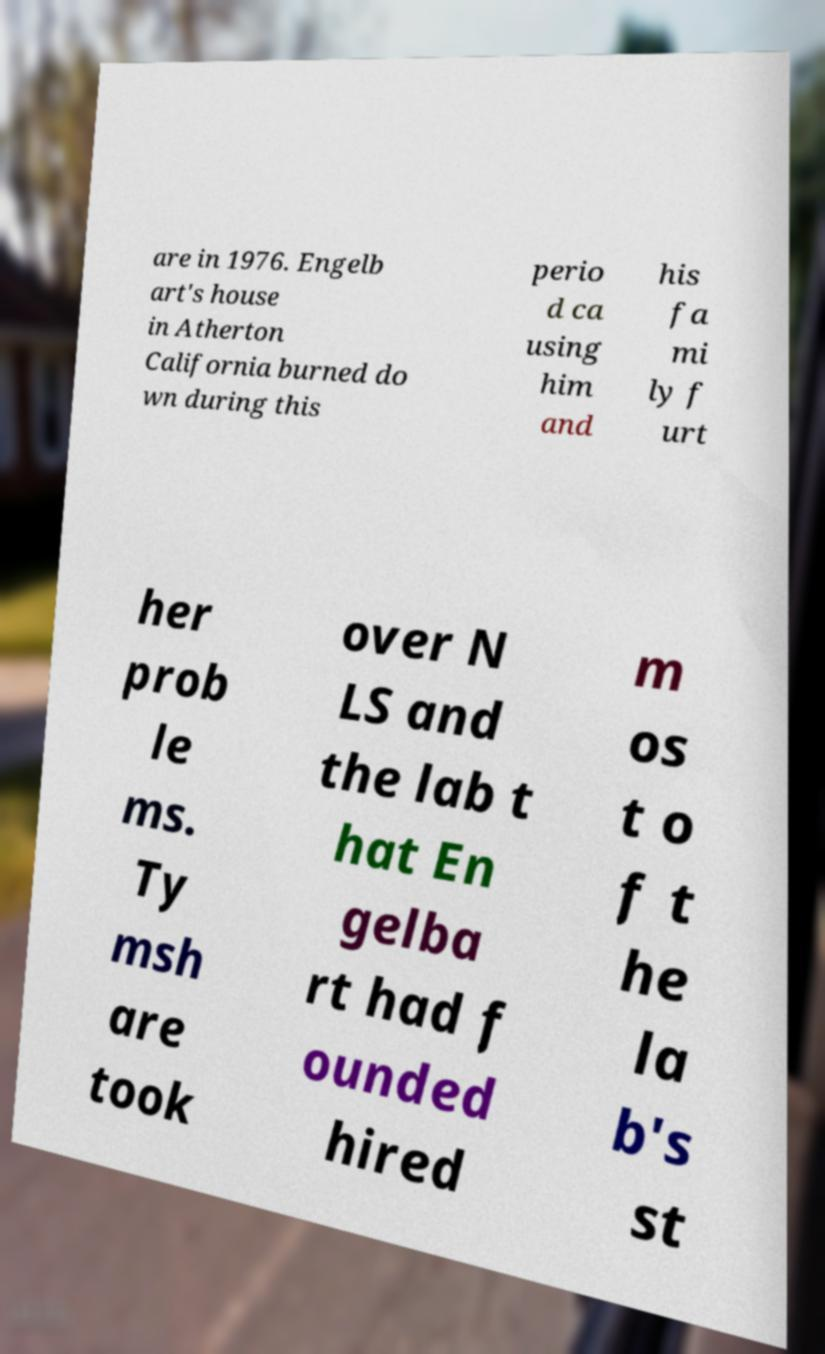Could you extract and type out the text from this image? are in 1976. Engelb art's house in Atherton California burned do wn during this perio d ca using him and his fa mi ly f urt her prob le ms. Ty msh are took over N LS and the lab t hat En gelba rt had f ounded hired m os t o f t he la b's st 